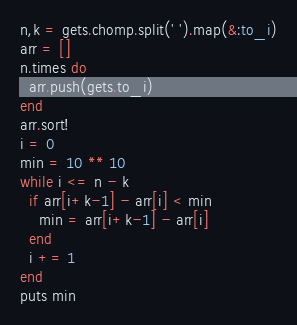<code> <loc_0><loc_0><loc_500><loc_500><_Ruby_>n,k = gets.chomp.split(' ').map(&:to_i)
arr = []
n.times do
  arr.push(gets.to_i)
end
arr.sort!
i = 0
min = 10 ** 10
while i <= n - k
  if arr[i+k-1] - arr[i] < min
    min = arr[i+k-1] - arr[i]
  end
  i += 1
end
puts min</code> 